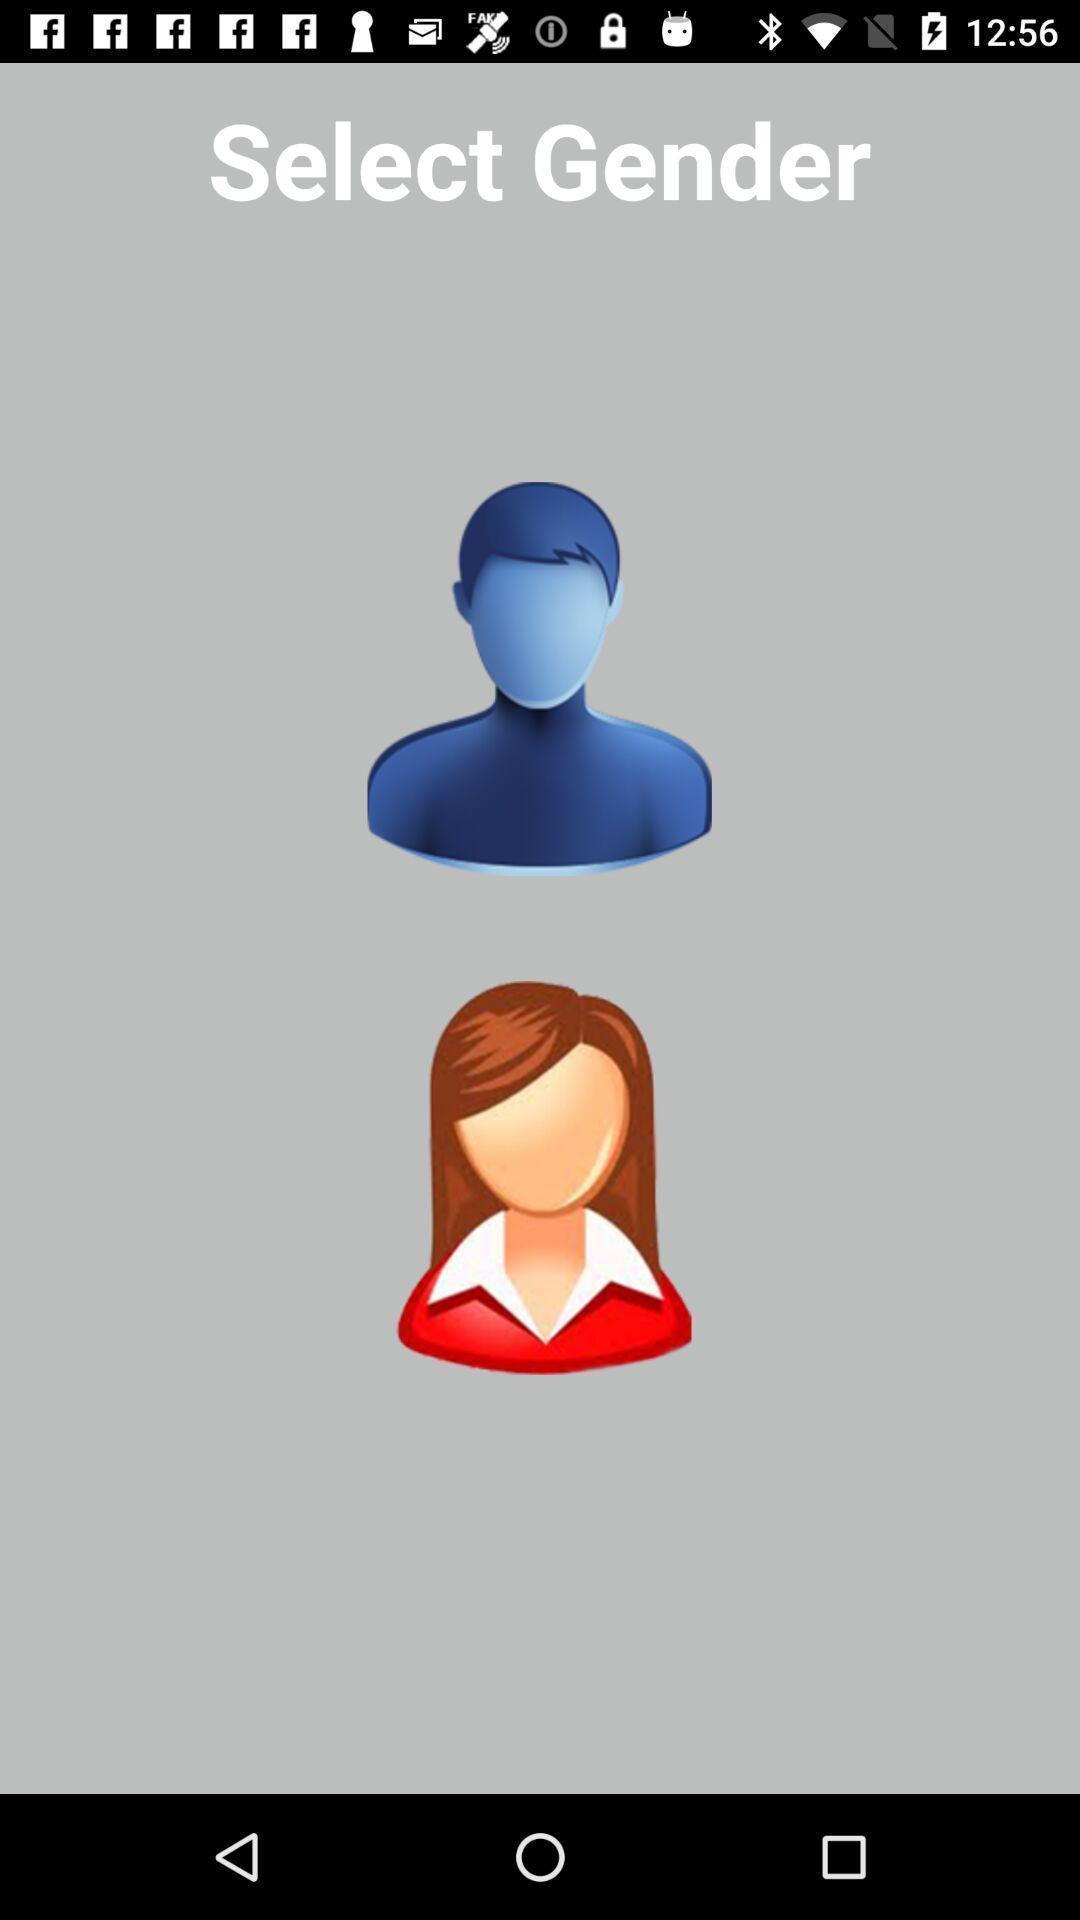What can you discern from this picture? Page showing to select gender. 